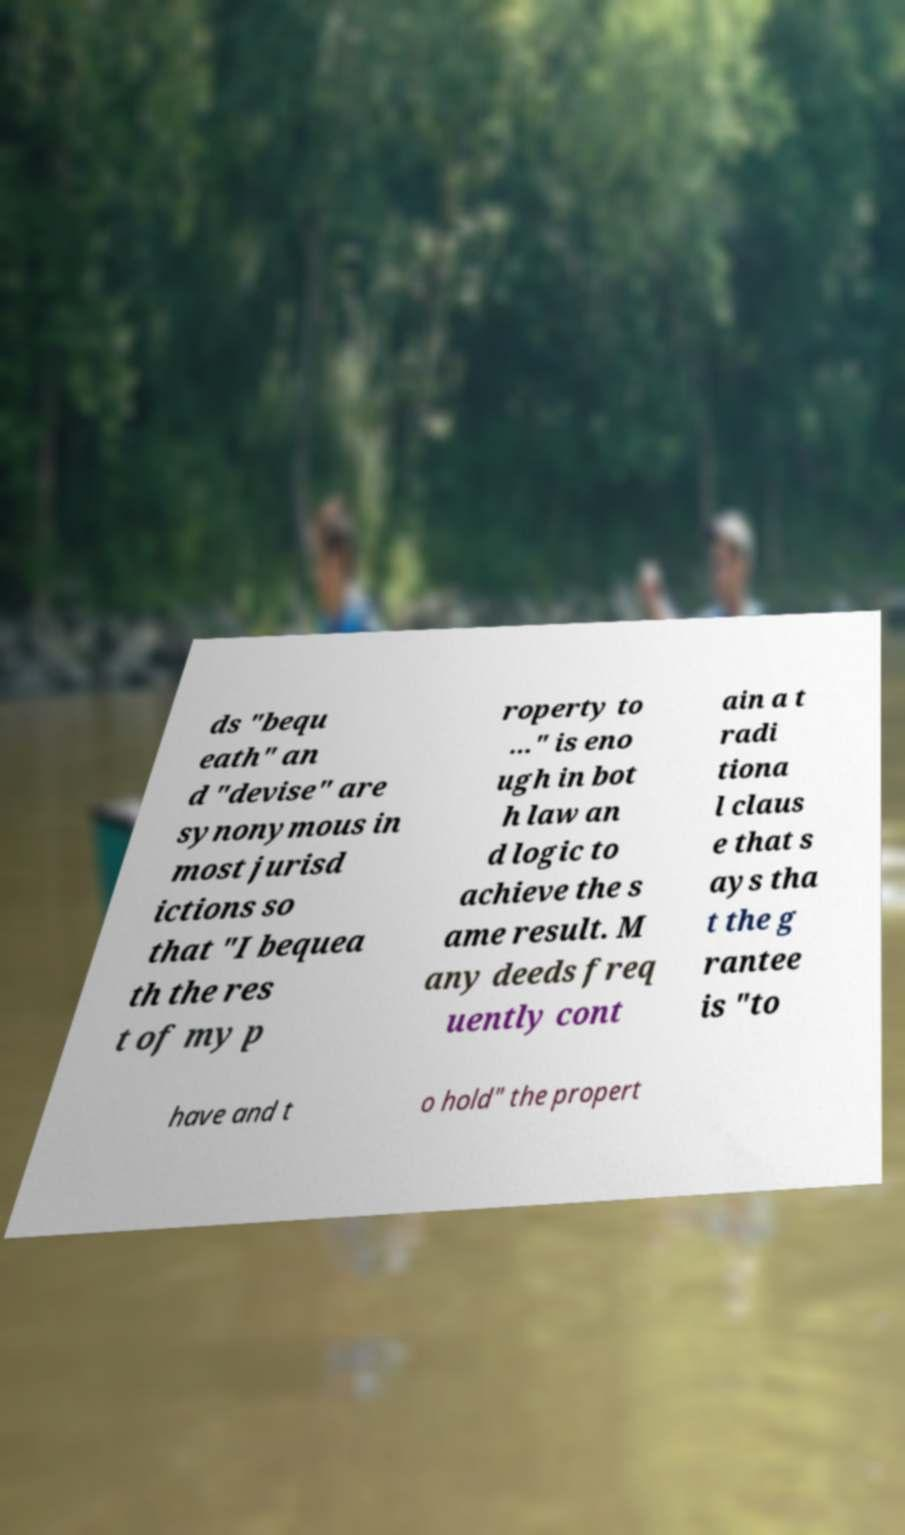There's text embedded in this image that I need extracted. Can you transcribe it verbatim? ds "bequ eath" an d "devise" are synonymous in most jurisd ictions so that "I bequea th the res t of my p roperty to ..." is eno ugh in bot h law an d logic to achieve the s ame result. M any deeds freq uently cont ain a t radi tiona l claus e that s ays tha t the g rantee is "to have and t o hold" the propert 